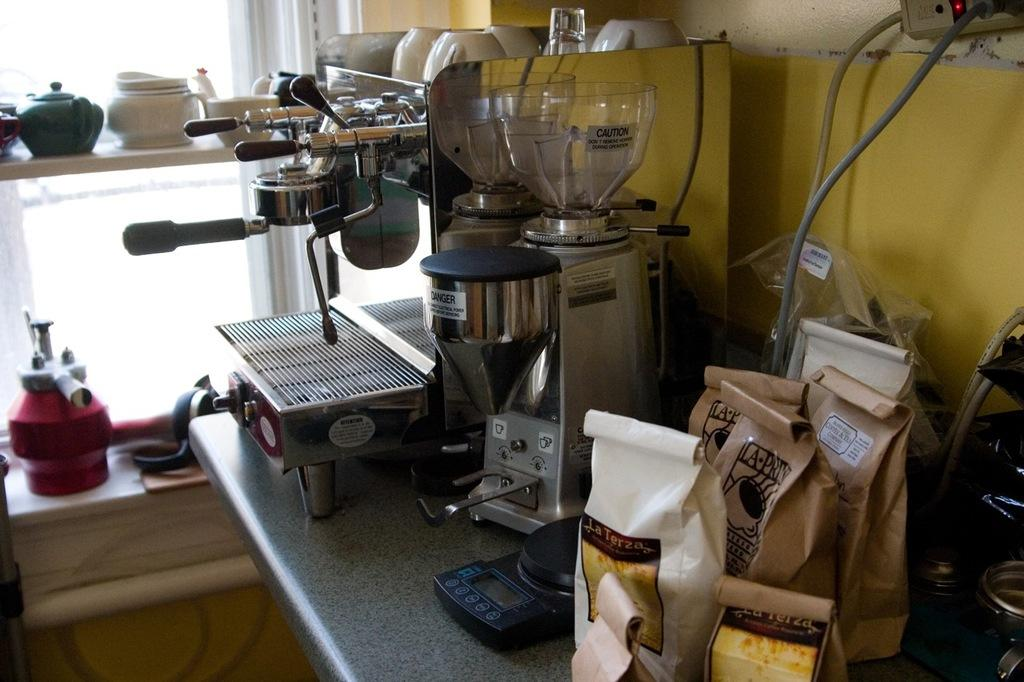<image>
Relay a brief, clear account of the picture shown. an espresso machine with coffee bags like La Terza next to it 